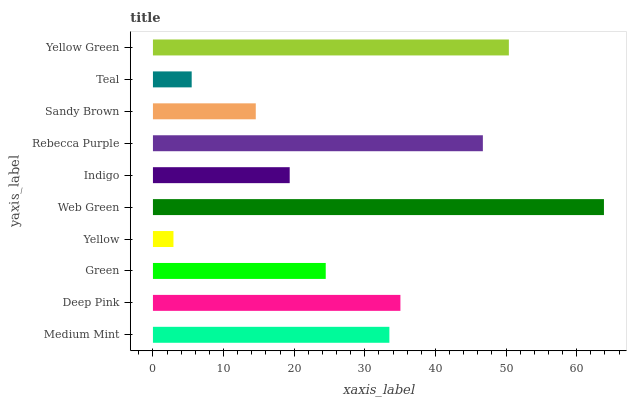Is Yellow the minimum?
Answer yes or no. Yes. Is Web Green the maximum?
Answer yes or no. Yes. Is Deep Pink the minimum?
Answer yes or no. No. Is Deep Pink the maximum?
Answer yes or no. No. Is Deep Pink greater than Medium Mint?
Answer yes or no. Yes. Is Medium Mint less than Deep Pink?
Answer yes or no. Yes. Is Medium Mint greater than Deep Pink?
Answer yes or no. No. Is Deep Pink less than Medium Mint?
Answer yes or no. No. Is Medium Mint the high median?
Answer yes or no. Yes. Is Green the low median?
Answer yes or no. Yes. Is Web Green the high median?
Answer yes or no. No. Is Indigo the low median?
Answer yes or no. No. 